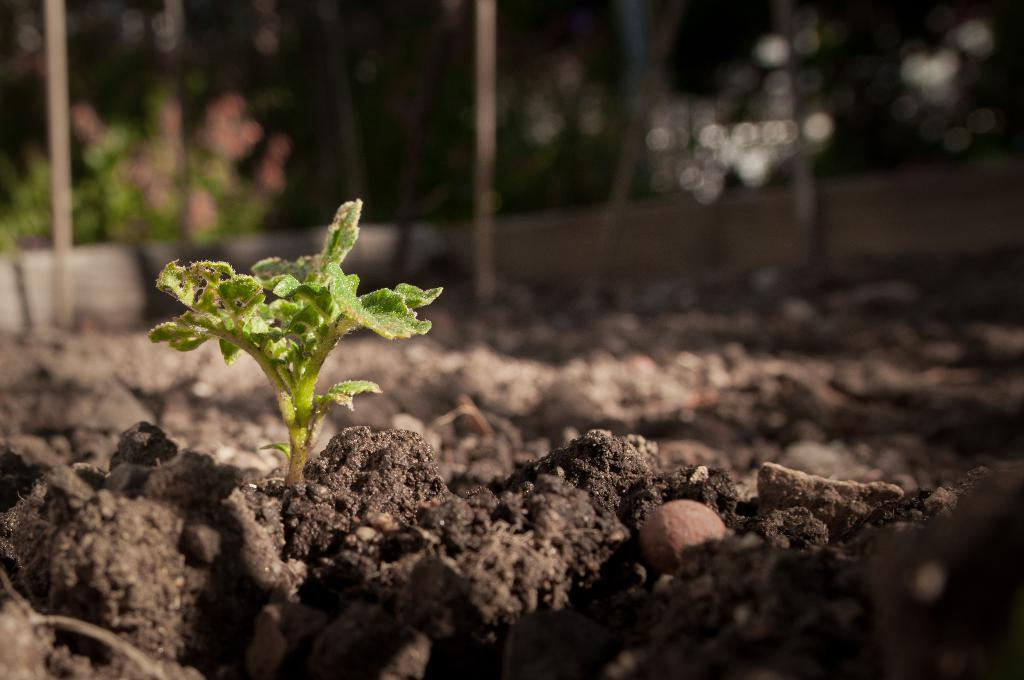What type of plant can be seen in the image? There is a plant in the image. What is present around the plant? Soil is present around the plant in the image. What can be seen in the background of the image? There are trees and poles in the background of the image. How would you describe the overall clarity of the image? The image is blurry. Can you see a tent in the image? There is no tent present in the image. What type of comb is being used to groom the plant in the image? There is no comb visible in the image, and plants do not require grooming. 